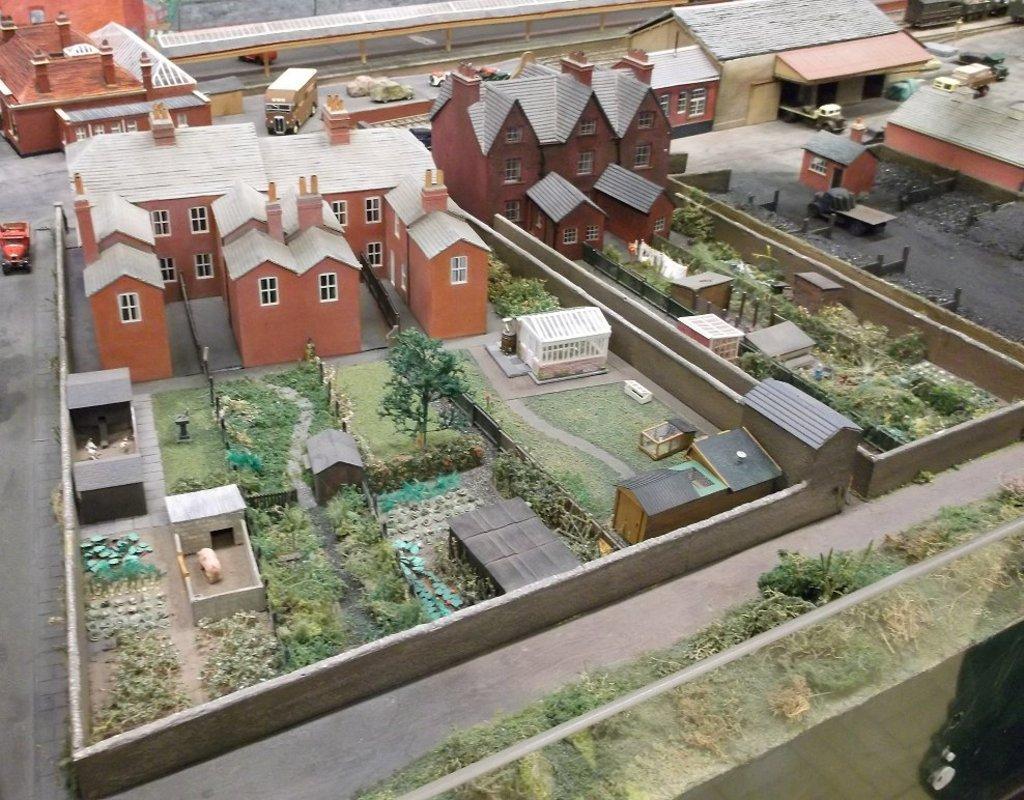Can you describe this image briefly? In this image we can see model of houses. In front of the houses garden is there and on road vehicle are present. 